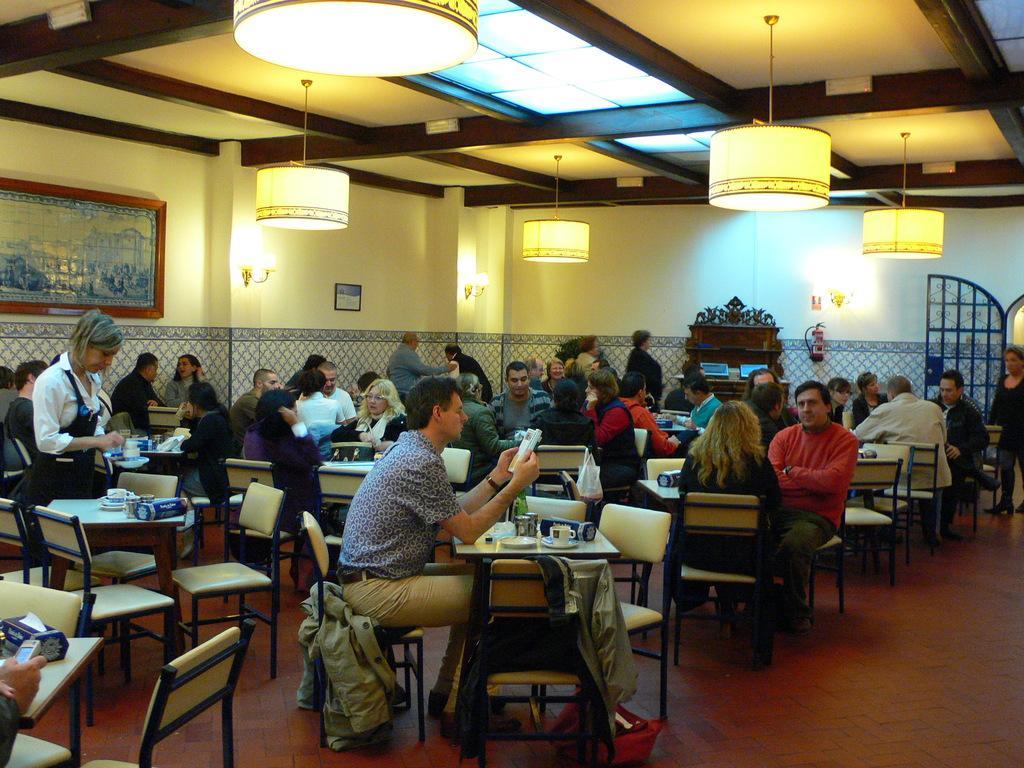In one or two sentences, can you explain what this image depicts? Most of the persons are sitting on a chair. In-front of this person there are tables, on this table there is a cup, plate and things. This woman is standing. A picture on wall. On top there are lights. On this chair there is a jacket. 